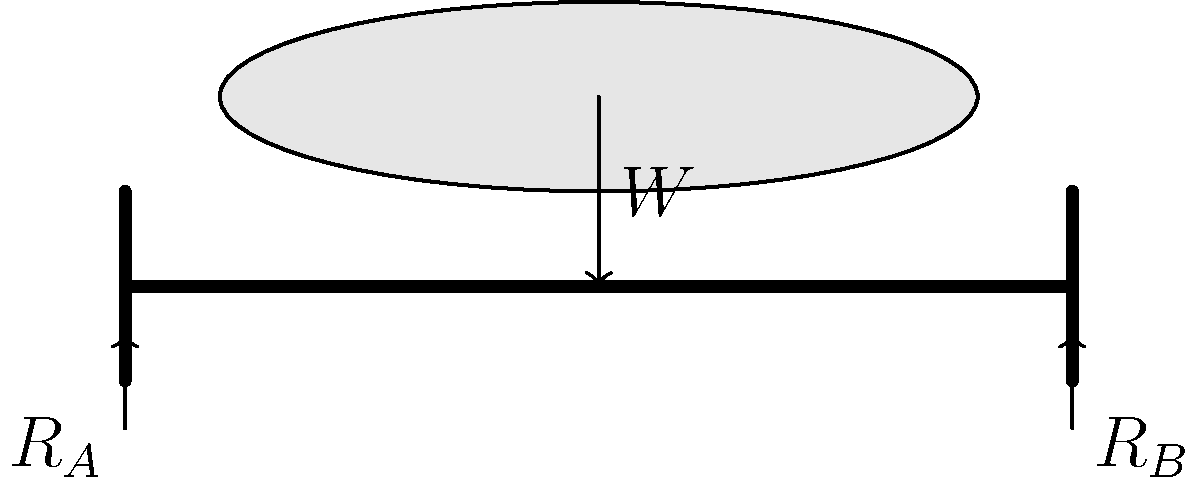A decorative ceiling feature weighing $W = 500$ N is suspended from the center of a simply supported beam of length $L = 4$ m. Calculate the reaction forces $R_A$ and $R_B$ at the beam supports. To solve this problem, we'll use the principles of static equilibrium. The steps are as follows:

1) First, we recognize that the beam is in static equilibrium, so the sum of all forces and moments must equal zero.

2) For vertical force equilibrium:
   $$\sum F_y = 0$$
   $$R_A + R_B - W = 0$$
   $$R_A + R_B = W = 500 \text{ N}$$

3) For moment equilibrium, let's take moments about point A:
   $$\sum M_A = 0$$
   $$R_B \cdot L - W \cdot \frac{L}{2} = 0$$
   $$R_B \cdot 4 - 500 \cdot 2 = 0$$
   $$R_B \cdot 4 = 1000$$
   $$R_B = 250 \text{ N}$$

4) Now that we know $R_B$, we can find $R_A$ using the equation from step 2:
   $$R_A + 250 = 500$$
   $$R_A = 250 \text{ N}$$

5) We can verify this result by noting that the load is centered, so the reactions should be equal.

Therefore, the reaction forces at both supports A and B are 250 N each.
Answer: $R_A = R_B = 250 \text{ N}$ 